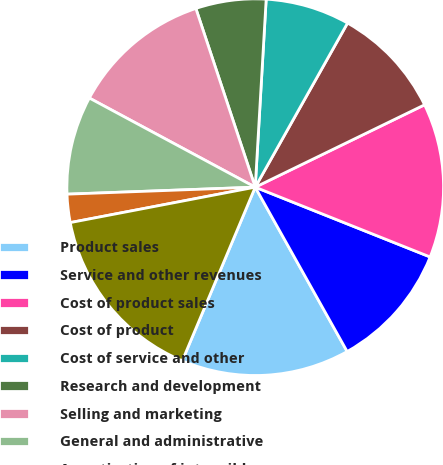Convert chart to OTSL. <chart><loc_0><loc_0><loc_500><loc_500><pie_chart><fcel>Product sales<fcel>Service and other revenues<fcel>Cost of product sales<fcel>Cost of product<fcel>Cost of service and other<fcel>Research and development<fcel>Selling and marketing<fcel>General and administrative<fcel>Amortization of intangible<fcel>(Loss) income from operations<nl><fcel>14.45%<fcel>10.84%<fcel>13.25%<fcel>9.64%<fcel>7.23%<fcel>6.03%<fcel>12.05%<fcel>8.44%<fcel>2.42%<fcel>15.66%<nl></chart> 